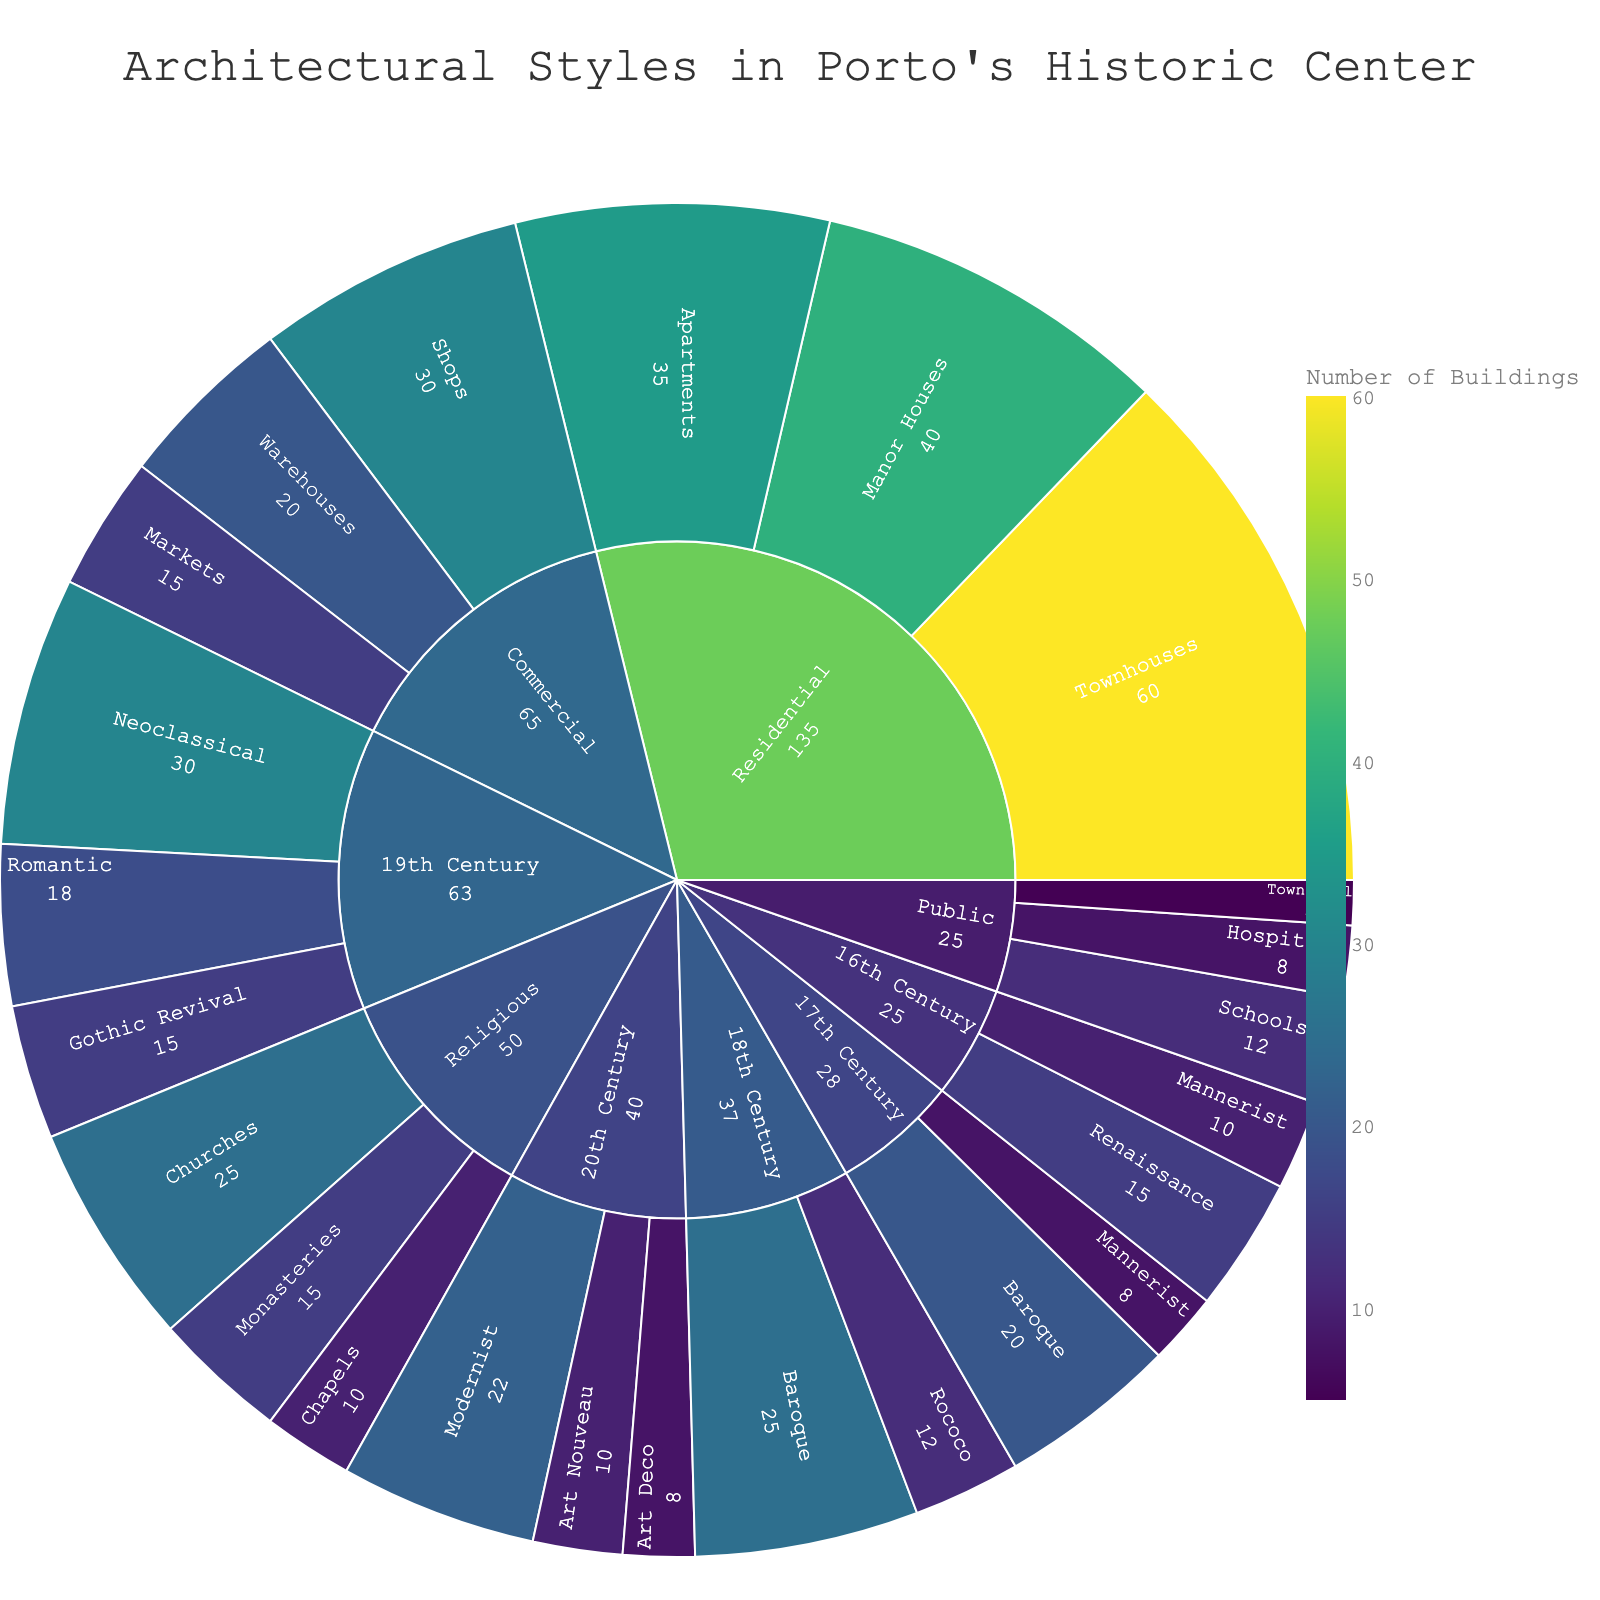What is the main title of the sunburst plot? The main title is usually found at the top of the plot. It summarizes the overall theme or subject of the visualization. In this plot, the title is: "Architectural Styles in Porto's Historic Center".
Answer: Architectural Styles in Porto's Historic Center Which architectural style from the 16th Century has the highest number of buildings? Look at the section under the '16th Century' category and find the subcategory with the highest value. The Mannerist style has 10 buildings, and the Renaissance style has 15 buildings. So, the Renaissance style has the highest number.
Answer: Renaissance How many categories of building types are represented in the plot? Identify the main categories, which are the broadest levels of the sunburst plot. The categories represented are Residential, Religious, Commercial, and Public. Count these categories to get the answer.
Answer: 4 What is the total number of buildings listed under the Residential category? Summing up the values of the subcategories under 'Residential': Manor Houses (40), Townhouses (60), and Apartments (35). The total is 40 + 60 + 35 = 135 buildings.
Answer: 135 Which century has the most architectural styles represented, and how many styles are there? Count the number of subcategories under each century. The 19th Century has Neoclassical, Romantic, and Gothic Revival, totaling 3 styles. The other centuries have fewer styles.
Answer: 19th Century with 3 styles How does the number of Baroque buildings in the 18th Century compare to those in the 17th Century? Locate the Baroque subcategory under both the 18th Century and 17th Century. The 18th Century has 25 Baroque buildings and the 17th Century has 20. Comparing these, the 18th Century has 5 more Baroque buildings.
Answer: The 18th Century has 5 more Baroque buildings What is the combined total of Commercial and Religious buildings? Sum the values of the subcategories under both categories. For Commercial: Shops (30), Warehouses (20), Markets (15) give 65. For Religious: Churches (25), Monasteries (15), Chapels (10) total 50. Adding them together, 65 + 50 = 115.
Answer: 115 Which building type has the highest single value, and what is that value? Examine each subcategory value to find the highest. The highest single value is found under Residential with Townhouses having a value of 60.
Answer: Townhouses with 60 What is the ratio of 20th Century buildings to 16th Century buildings? Sum the values for each century. For the 20th Century: Art Nouveau (10), Modernist (22), Art Deco (8) totals 40. For the 16th Century: Mannerist (10), Renaissance (15) totals 25. The ratio is 40:25, which simplifies to 8:5.
Answer: 8:5 Which public building type has the lowest number of buildings, and what is that value? Look under the 'Public' category and identify the subcategory with the lowest value. The Town Hall has the lowest with 5 buildings.
Answer: Town Hall with 5 